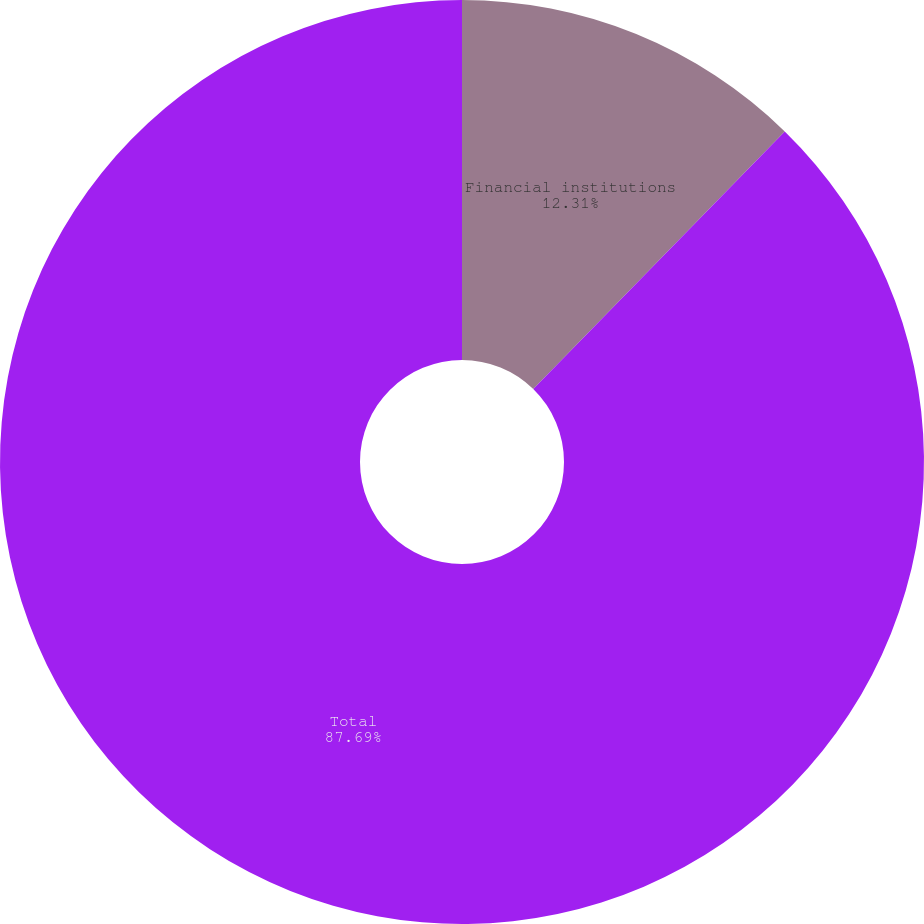<chart> <loc_0><loc_0><loc_500><loc_500><pie_chart><fcel>Financial institutions<fcel>Total<nl><fcel>12.31%<fcel>87.69%<nl></chart> 